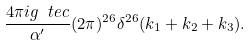<formula> <loc_0><loc_0><loc_500><loc_500>\frac { 4 \pi i g _ { \ } t e { c } } { \alpha ^ { \prime } } ( 2 \pi ) ^ { 2 6 } \delta ^ { 2 6 } ( k _ { 1 } + k _ { 2 } + k _ { 3 } ) .</formula> 